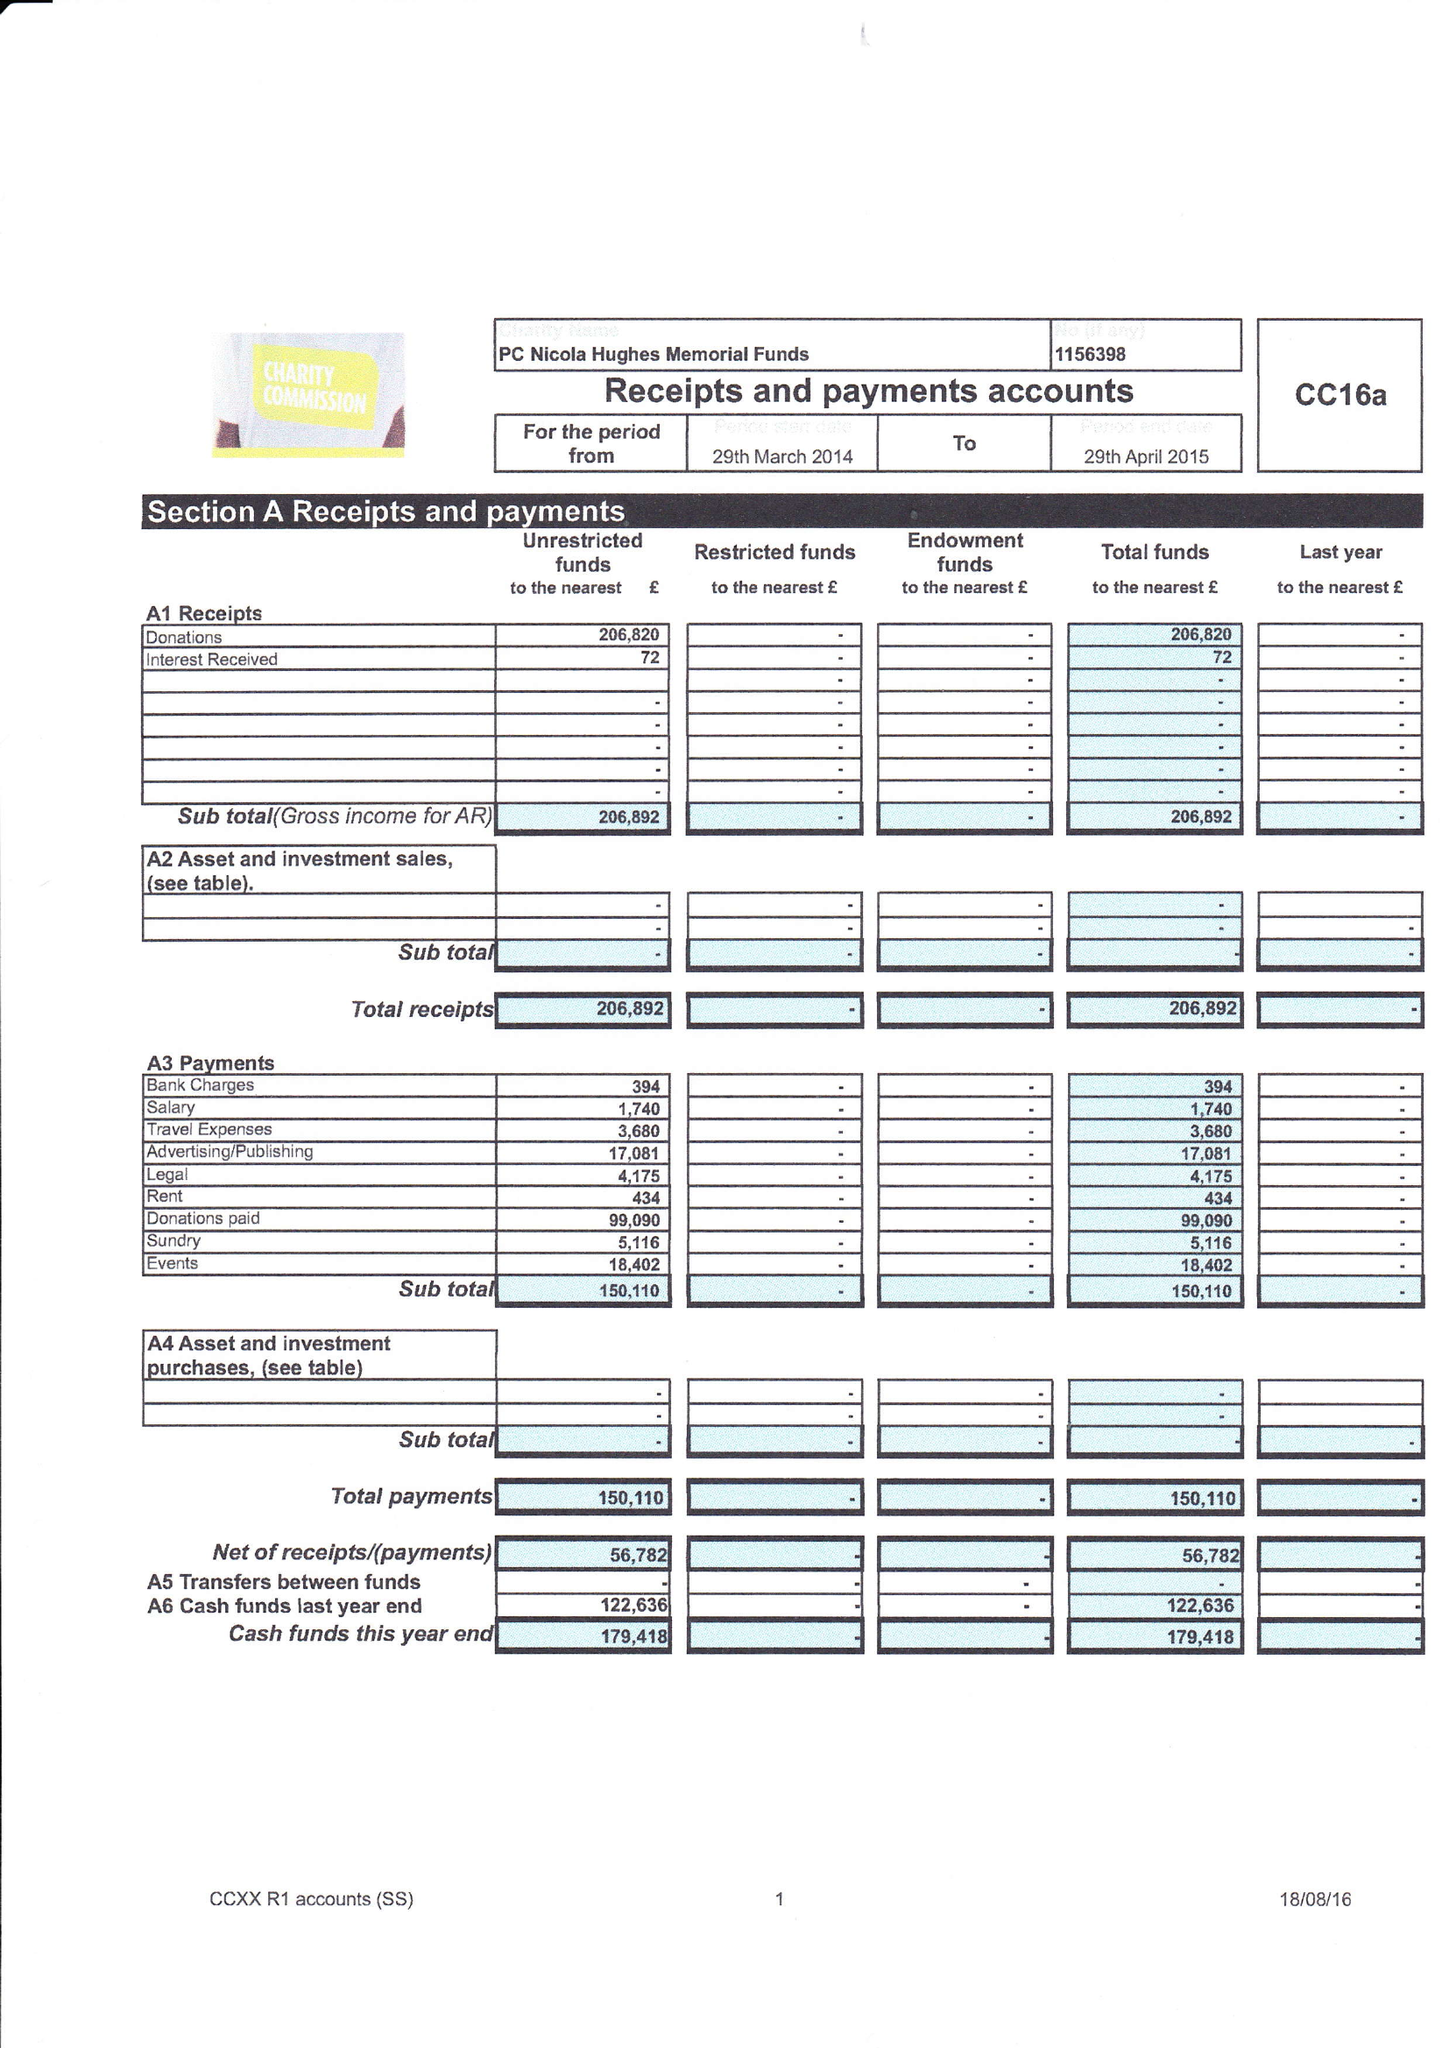What is the value for the report_date?
Answer the question using a single word or phrase. 2015-04-29 